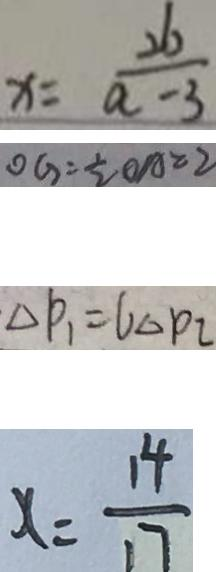Convert formula to latex. <formula><loc_0><loc_0><loc_500><loc_500>x = \frac { 2 6 } { a - 3 } 
 O G = \frac { 1 } { 2 } O A = 2 
 \Delta P _ { 1 } = 6 \Delta p _ { 2 } 
 x = \frac { 1 4 } { 1 7 }</formula> 